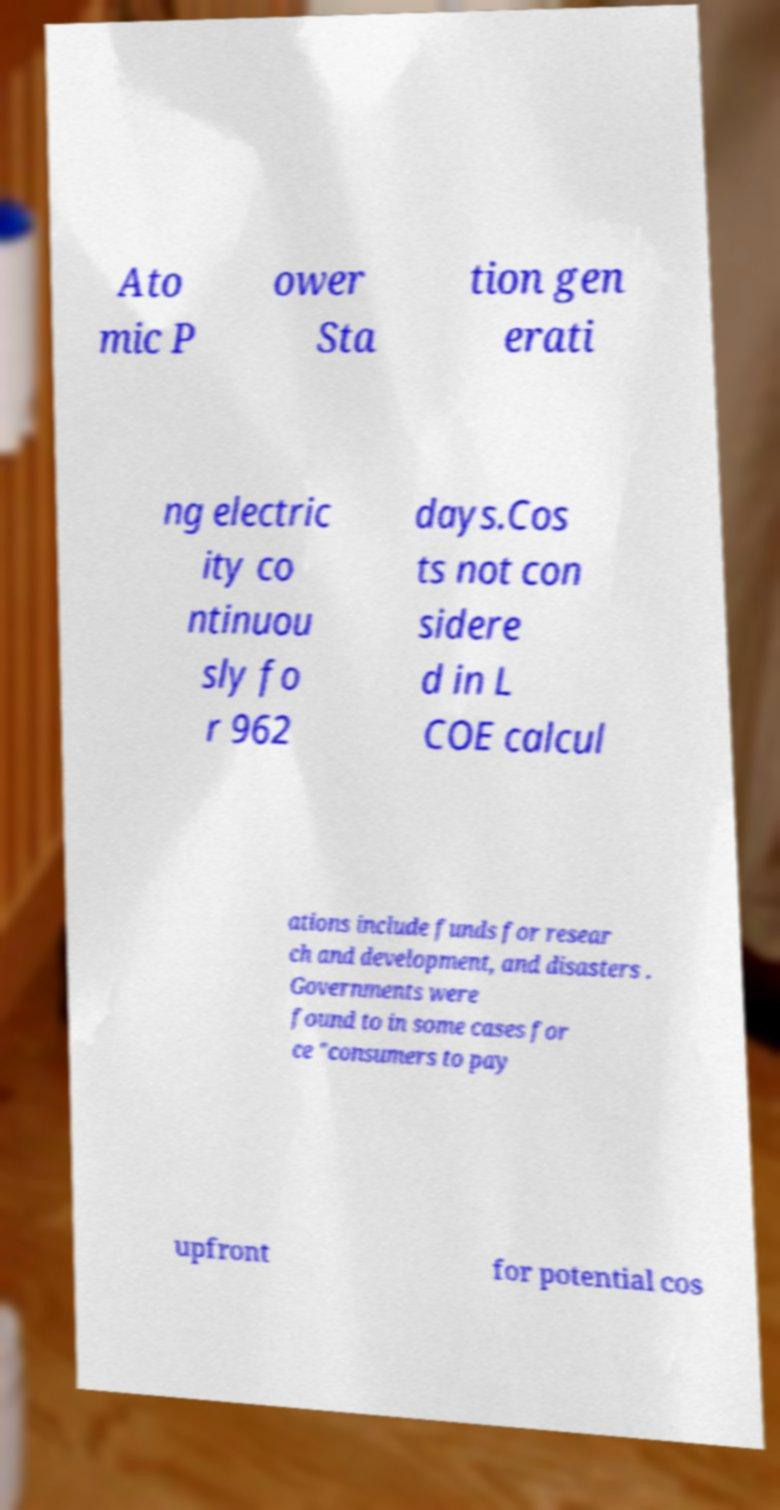Can you accurately transcribe the text from the provided image for me? Ato mic P ower Sta tion gen erati ng electric ity co ntinuou sly fo r 962 days.Cos ts not con sidere d in L COE calcul ations include funds for resear ch and development, and disasters . Governments were found to in some cases for ce "consumers to pay upfront for potential cos 